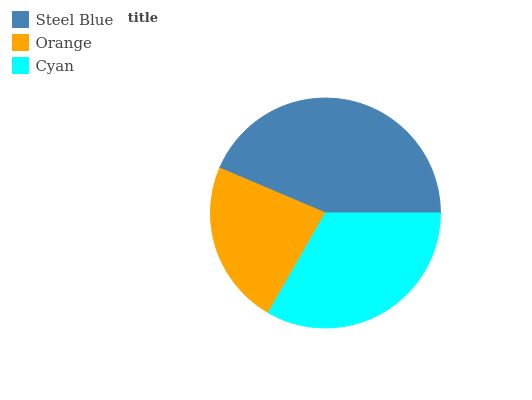Is Orange the minimum?
Answer yes or no. Yes. Is Steel Blue the maximum?
Answer yes or no. Yes. Is Cyan the minimum?
Answer yes or no. No. Is Cyan the maximum?
Answer yes or no. No. Is Cyan greater than Orange?
Answer yes or no. Yes. Is Orange less than Cyan?
Answer yes or no. Yes. Is Orange greater than Cyan?
Answer yes or no. No. Is Cyan less than Orange?
Answer yes or no. No. Is Cyan the high median?
Answer yes or no. Yes. Is Cyan the low median?
Answer yes or no. Yes. Is Steel Blue the high median?
Answer yes or no. No. Is Steel Blue the low median?
Answer yes or no. No. 